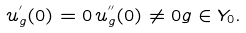<formula> <loc_0><loc_0><loc_500><loc_500>u ^ { ^ { \prime } } _ { g } ( 0 ) = 0 \, u ^ { ^ { \prime \prime } } _ { g } ( 0 ) \not = 0 g \in Y _ { 0 } .</formula> 